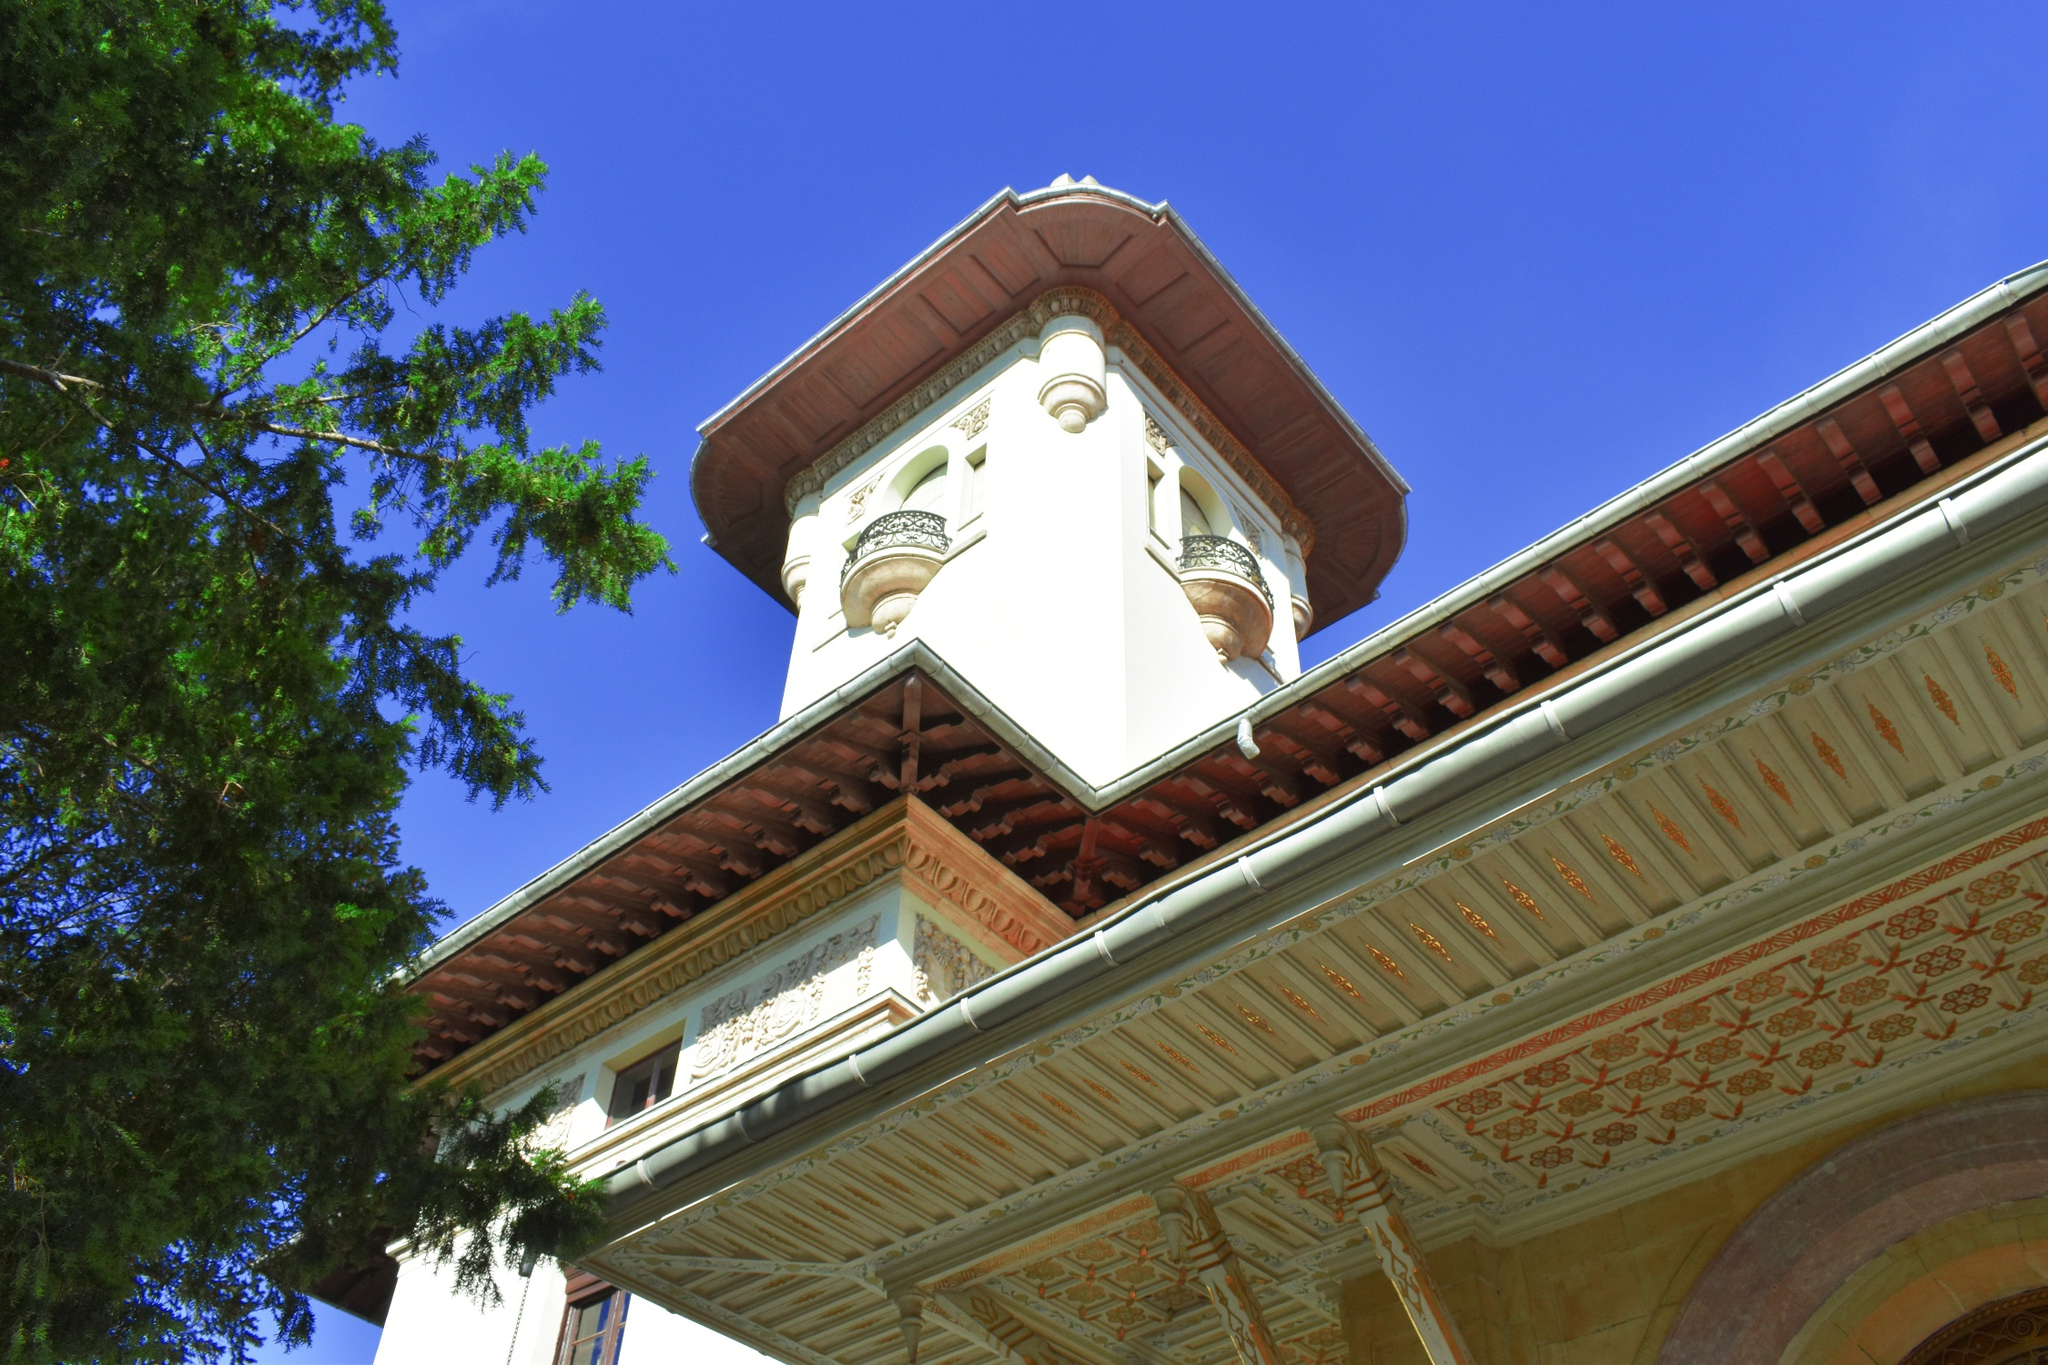Describe the atmosphere and mood conveyed by the architecture. The atmosphere conveyed by this architectural marvel is one of grandeur and elegance. The tall white tower, adorned with intricate details and topped with a vibrant red roof, exudes a sense of historical significance and timeless beauty. The low-angle perspective gives the viewer a sense of awe, making the structure appear imposing and majestic against the clear blue sky. The surrounding greenery adds a touch of tranquility, balancing the grandeur of the building with the serenity of nature. 